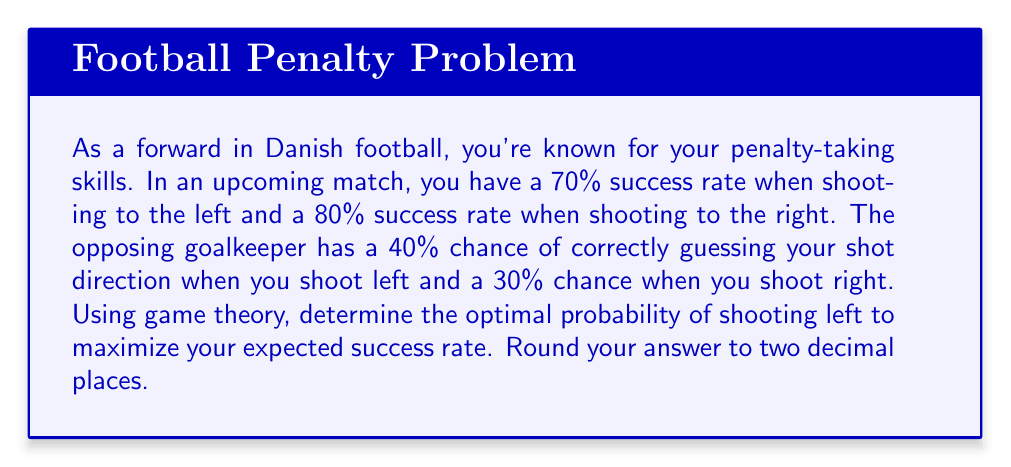Could you help me with this problem? Let's approach this problem using game theory principles:

1) First, let's define our variables:
   $p$ = probability of shooting left
   $1-p$ = probability of shooting right

2) Now, we can set up our expected success rate equation:
   $E(p) = 0.7p(1-0.4) + 0.8(1-p)(1-0.3)$

3) Simplify:
   $E(p) = 0.42p + 0.56(1-p)$
   $E(p) = 0.42p + 0.56 - 0.56p$
   $E(p) = 0.56 - 0.14p$

4) To find the maximum value of $E(p)$, we need to consider the following:
   - If the coefficient of $p$ is positive, the maximum occurs at $p=1$
   - If the coefficient of $p$ is negative, the maximum occurs at $p=0$
   - If the coefficient of $p$ is zero, any value of $p$ gives the same result

5) In our case, the coefficient of $p$ is $-0.14$, which is negative. This means the maximum occurs when $p=0$.

6) However, this suggests always shooting right, which is predictable and not optimal in a game situation. In game theory, we look for a mixed strategy that makes the opponent indifferent to their choice.

7) To find this, we set the expected outcome for the goalkeeper equal whether you shoot left or right:

   Left: $0.7(0.4) + 0.8(0.7) = 0.28 + 0.56 = 0.84$
   Right: $0.7(0.6) + 0.8(0.3) = 0.42 + 0.24 = 0.66$

8) Let $p$ be the probability of shooting left. Then:

   $0.84p + 0.66(1-p) = 0.84p + 0.66 - 0.66p = 0.66 + 0.18p$

9) Set this equal to the constant 0.7:

   $0.66 + 0.18p = 0.7$
   $0.18p = 0.04$
   $p = 0.04 / 0.18 = 0.2222...$

10) Rounding to two decimal places gives us 0.22.
Answer: The optimal probability of shooting left is 0.22 or 22%. 